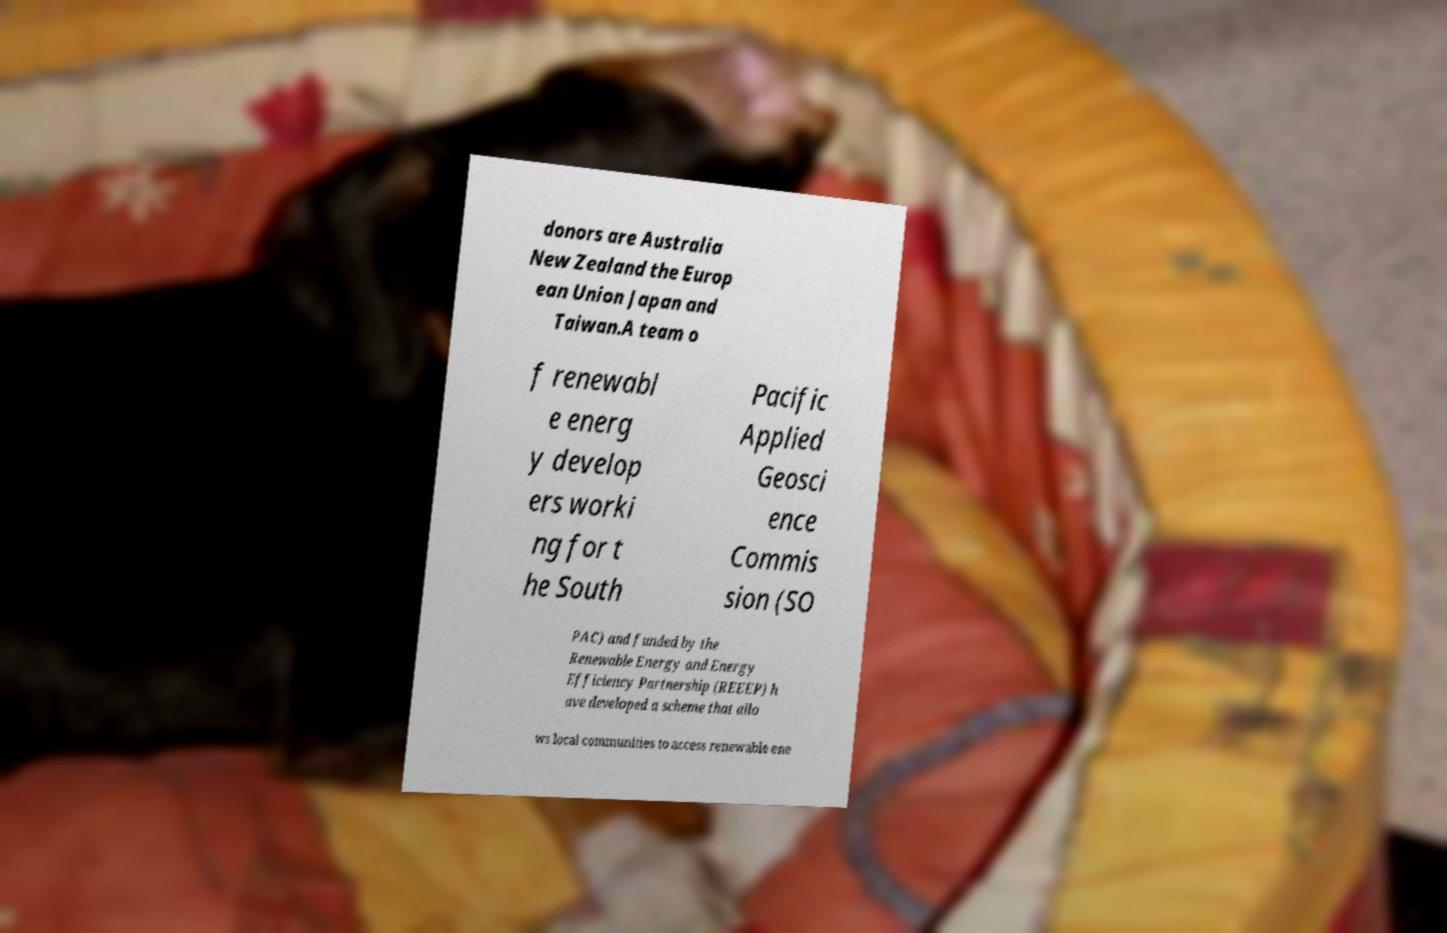Please identify and transcribe the text found in this image. donors are Australia New Zealand the Europ ean Union Japan and Taiwan.A team o f renewabl e energ y develop ers worki ng for t he South Pacific Applied Geosci ence Commis sion (SO PAC) and funded by the Renewable Energy and Energy Efficiency Partnership (REEEP) h ave developed a scheme that allo ws local communities to access renewable ene 